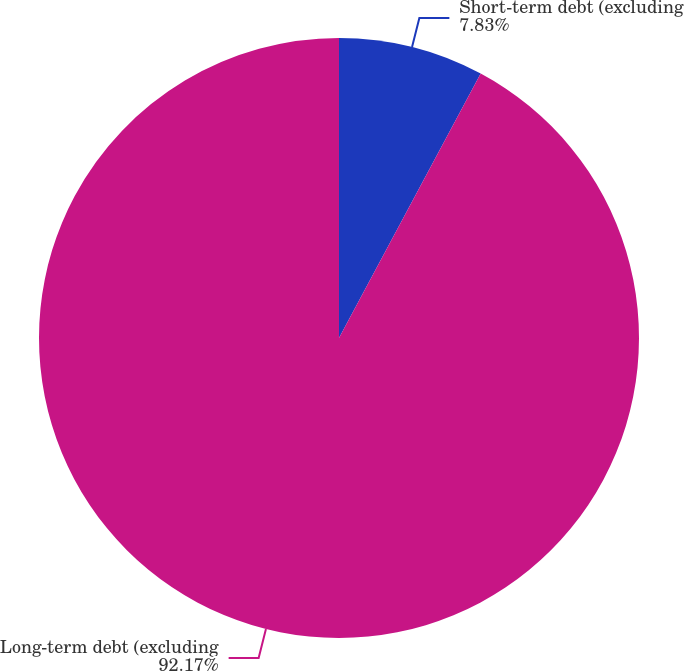Convert chart. <chart><loc_0><loc_0><loc_500><loc_500><pie_chart><fcel>Short-term debt (excluding<fcel>Long-term debt (excluding<nl><fcel>7.83%<fcel>92.17%<nl></chart> 